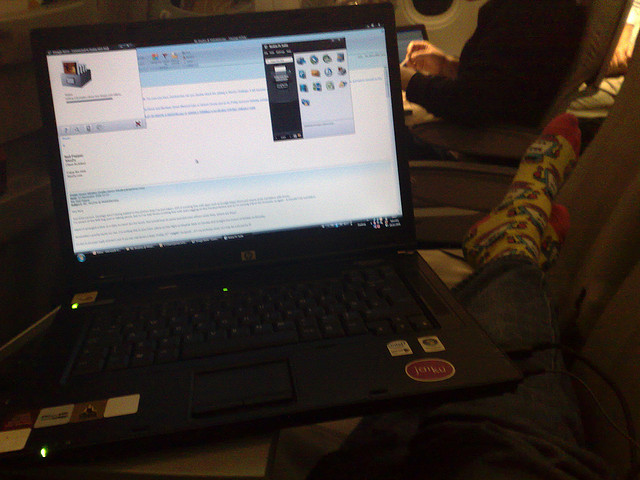What does the image suggest about the ergonomics of the user's setup? The user's setup, illustrated by the laptop placed on the thighs and the relaxed leg position, suggests a casual use rather than an ergonomic work environment. Long durations in such a posture could lead to discomfort, indicating that this arrangement is likely temporary or for short-term use. 